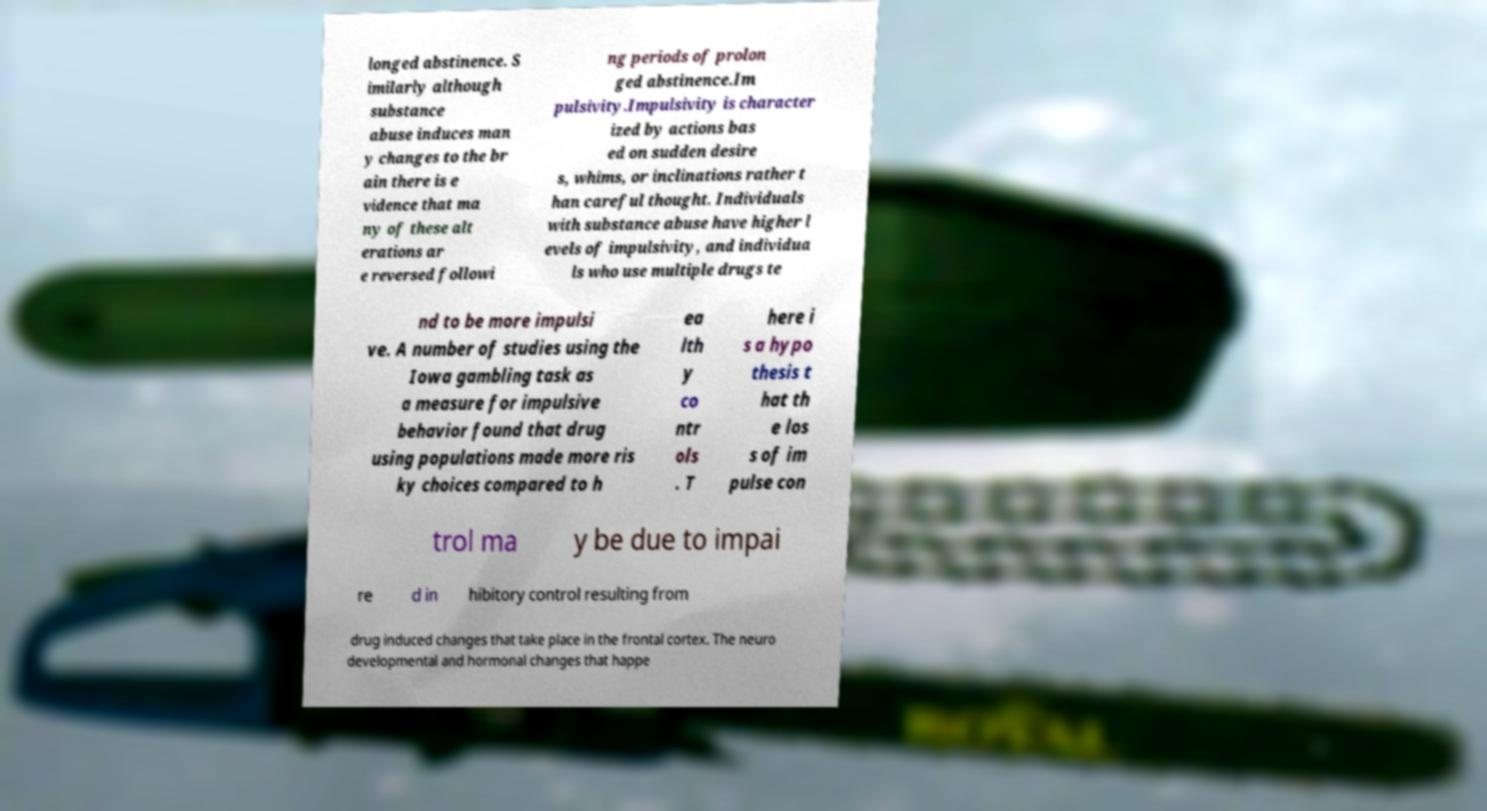There's text embedded in this image that I need extracted. Can you transcribe it verbatim? longed abstinence. S imilarly although substance abuse induces man y changes to the br ain there is e vidence that ma ny of these alt erations ar e reversed followi ng periods of prolon ged abstinence.Im pulsivity.Impulsivity is character ized by actions bas ed on sudden desire s, whims, or inclinations rather t han careful thought. Individuals with substance abuse have higher l evels of impulsivity, and individua ls who use multiple drugs te nd to be more impulsi ve. A number of studies using the Iowa gambling task as a measure for impulsive behavior found that drug using populations made more ris ky choices compared to h ea lth y co ntr ols . T here i s a hypo thesis t hat th e los s of im pulse con trol ma y be due to impai re d in hibitory control resulting from drug induced changes that take place in the frontal cortex. The neuro developmental and hormonal changes that happe 